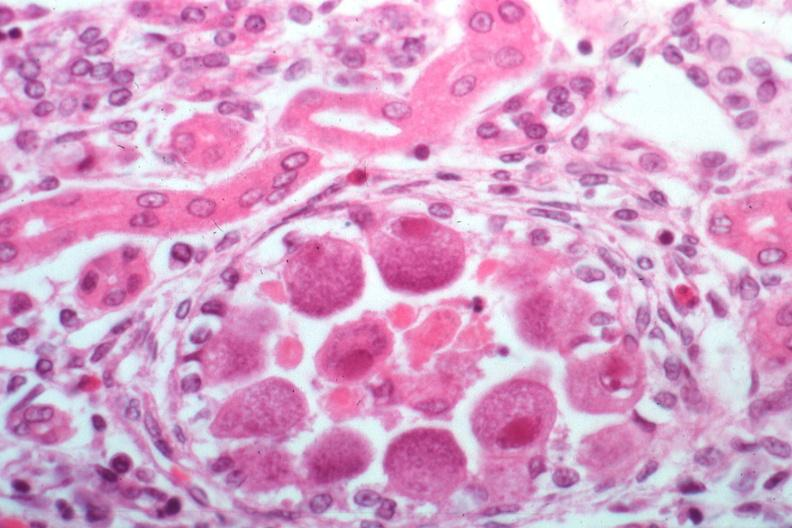s cytomegalovirus present?
Answer the question using a single word or phrase. Yes 